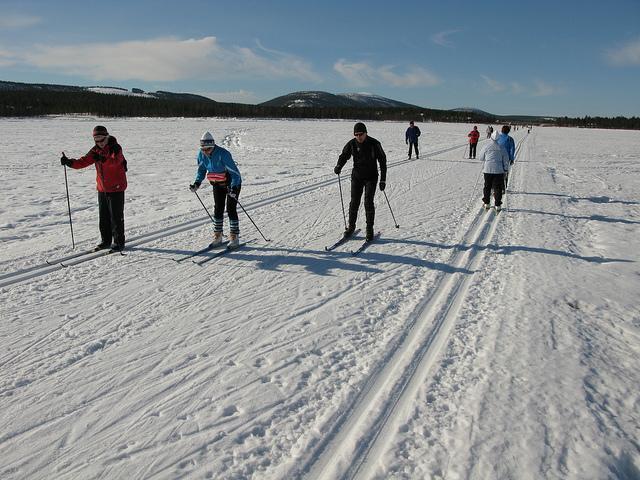How many people are in the photo?
Give a very brief answer. 3. 